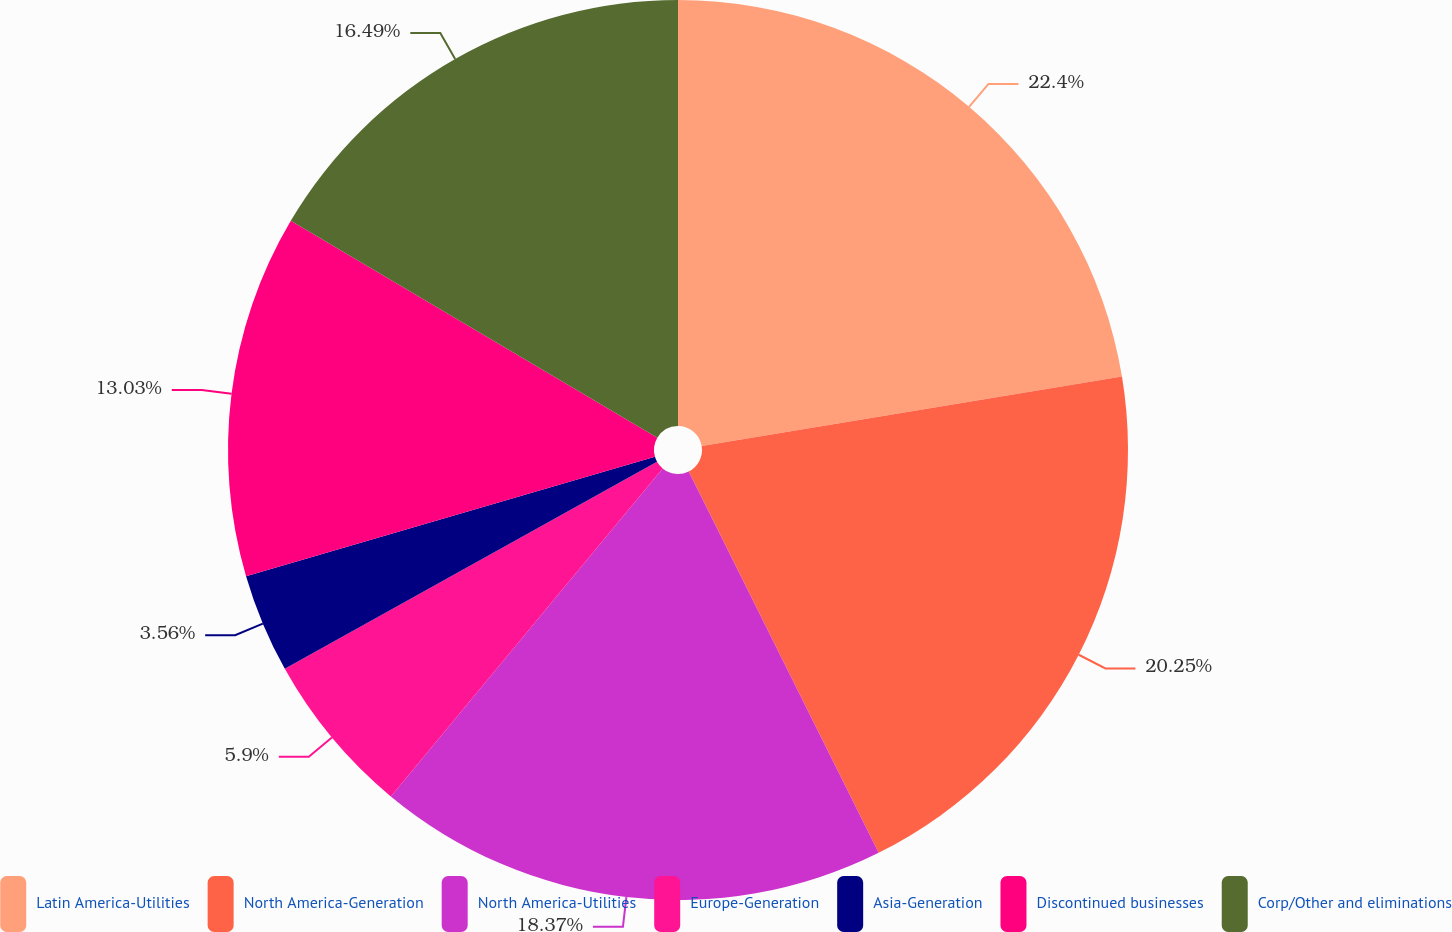Convert chart to OTSL. <chart><loc_0><loc_0><loc_500><loc_500><pie_chart><fcel>Latin America-Utilities<fcel>North America-Generation<fcel>North America-Utilities<fcel>Europe-Generation<fcel>Asia-Generation<fcel>Discontinued businesses<fcel>Corp/Other and eliminations<nl><fcel>22.39%<fcel>20.25%<fcel>18.37%<fcel>5.9%<fcel>3.56%<fcel>13.03%<fcel>16.49%<nl></chart> 